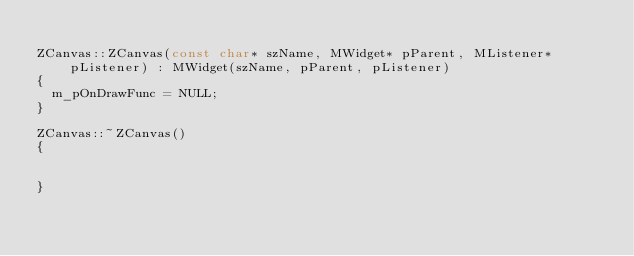<code> <loc_0><loc_0><loc_500><loc_500><_C++_>
ZCanvas::ZCanvas(const char* szName, MWidget* pParent, MListener* pListener) : MWidget(szName, pParent, pListener)
{
	m_pOnDrawFunc = NULL;
}

ZCanvas::~ZCanvas()
{


}
</code> 